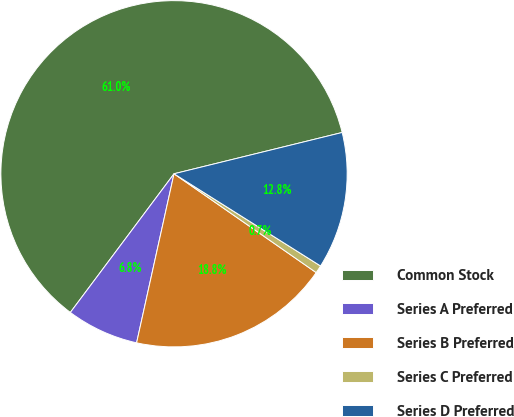<chart> <loc_0><loc_0><loc_500><loc_500><pie_chart><fcel>Common Stock<fcel>Series A Preferred<fcel>Series B Preferred<fcel>Series C Preferred<fcel>Series D Preferred<nl><fcel>60.95%<fcel>6.75%<fcel>18.8%<fcel>0.73%<fcel>12.77%<nl></chart> 